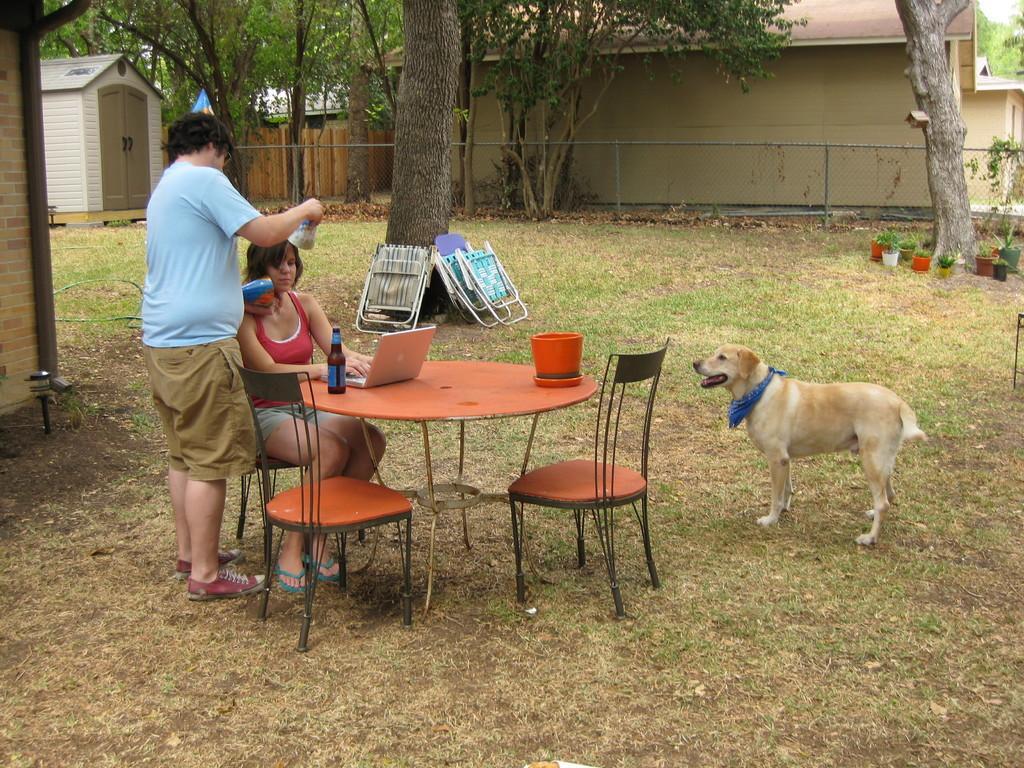Could you give a brief overview of what you see in this image? It is looking like a garden the woman is sitting on the chair, there is a table in front of her, upon the table there is a bottle and also a laptop beside her a man is standing and holding something with his hands there is a dog beside the table behind them there are some trees and in the background there is a wall to the left side there is a hut. 